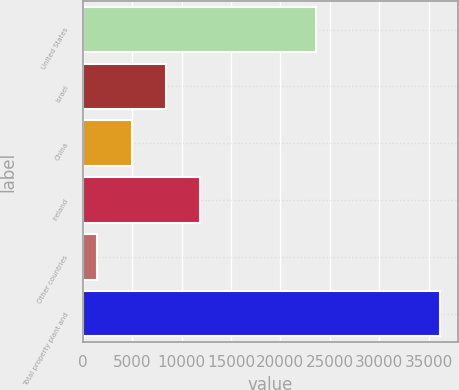Convert chart. <chart><loc_0><loc_0><loc_500><loc_500><bar_chart><fcel>United States<fcel>Israel<fcel>China<fcel>Ireland<fcel>Other countries<fcel>Total property plant and<nl><fcel>23598<fcel>8417.4<fcel>4948.2<fcel>11886.6<fcel>1479<fcel>36171<nl></chart> 